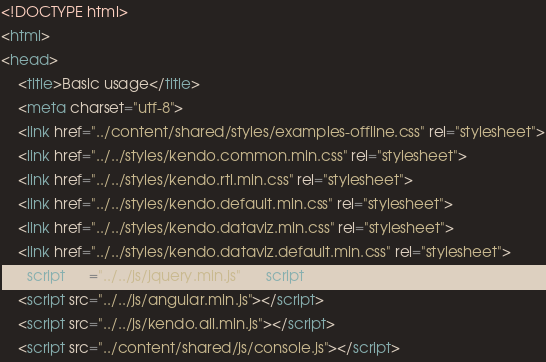Convert code to text. <code><loc_0><loc_0><loc_500><loc_500><_HTML_><!DOCTYPE html>
<html>
<head>
    <title>Basic usage</title>
    <meta charset="utf-8">
    <link href="../content/shared/styles/examples-offline.css" rel="stylesheet">
    <link href="../../styles/kendo.common.min.css" rel="stylesheet">
    <link href="../../styles/kendo.rtl.min.css" rel="stylesheet">
    <link href="../../styles/kendo.default.min.css" rel="stylesheet">
    <link href="../../styles/kendo.dataviz.min.css" rel="stylesheet">
    <link href="../../styles/kendo.dataviz.default.min.css" rel="stylesheet">
    <script src="../../js/jquery.min.js"></script>
    <script src="../../js/angular.min.js"></script>
    <script src="../../js/kendo.all.min.js"></script>
    <script src="../content/shared/js/console.js"></script></code> 